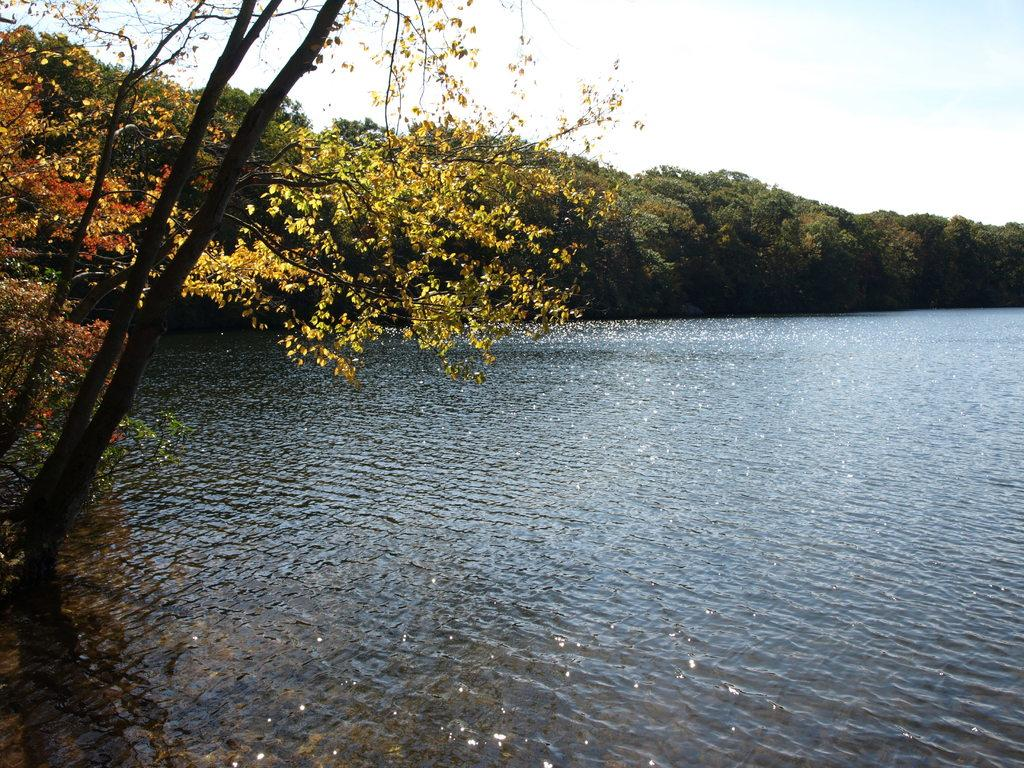What is visible in the image? Water is visible in the image. Where are the trees located in the image? There are trees on the left side of the image and also in the background. What can be seen in the sky in the background of the image? There are clouds in the sky in the background of the image. How many chances does the ant have to climb the chain in the image? There is no ant or chain present in the image. 